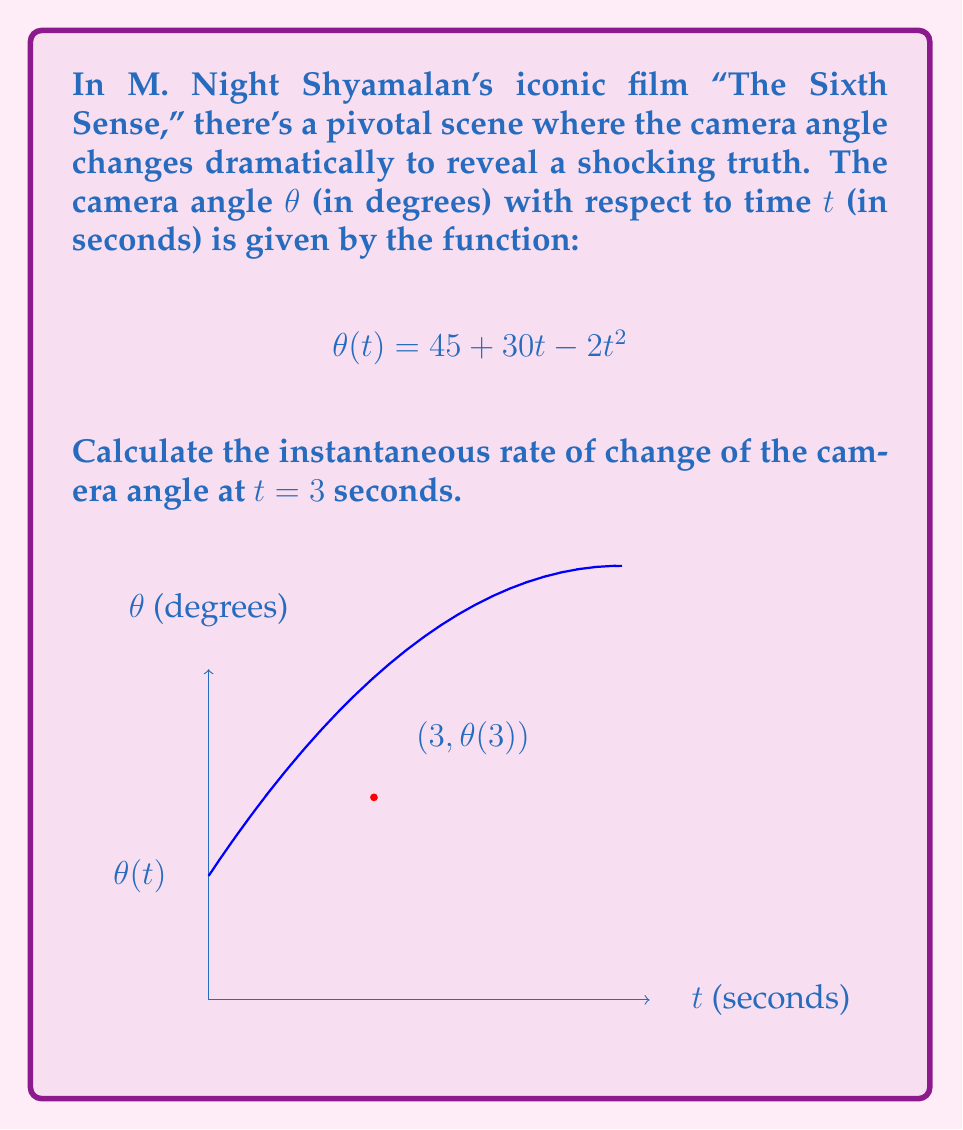Can you solve this math problem? To find the instantaneous rate of change of the camera angle at t = 3 seconds, we need to calculate the derivative of θ(t) and evaluate it at t = 3.

Step 1: Find the derivative of θ(t).
$$\frac{d}{dt}[θ(t)] = \frac{d}{dt}[45 + 30t - 2t^2]$$
$$θ'(t) = 0 + 30 - 4t$$

Step 2: Simplify the derivative.
$$θ'(t) = 30 - 4t$$

Step 3: Evaluate the derivative at t = 3.
$$θ'(3) = 30 - 4(3)$$
$$θ'(3) = 30 - 12$$
$$θ'(3) = 18$$

The instantaneous rate of change at t = 3 seconds is 18 degrees per second.

This rapid change in camera angle could represent the sudden revelation in Shyamalan's storytelling, typical of his signature plot twists.
Answer: $18$ degrees/second 